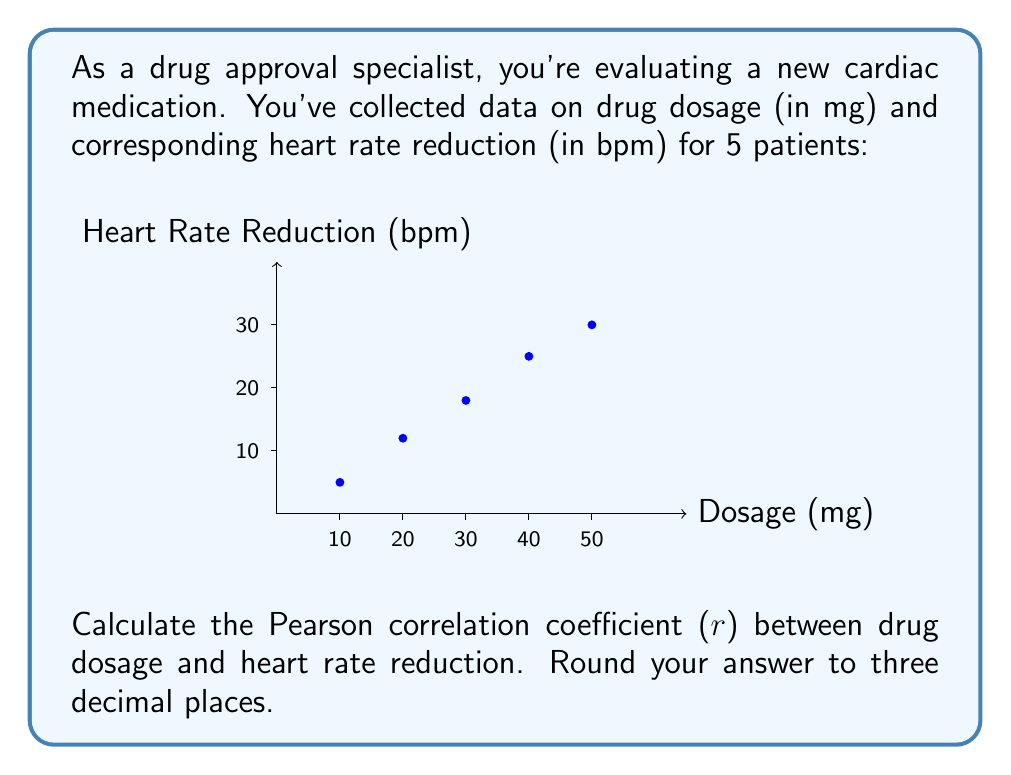Can you solve this math problem? To calculate the Pearson correlation coefficient, we'll use the formula:

$$ r = \frac{\sum_{i=1}^{n} (x_i - \bar{x})(y_i - \bar{y})}{\sqrt{\sum_{i=1}^{n} (x_i - \bar{x})^2} \sqrt{\sum_{i=1}^{n} (y_i - \bar{y})^2}} $$

Where:
$x_i$ = drug dosage
$y_i$ = heart rate reduction
$\bar{x}$ = mean drug dosage
$\bar{y}$ = mean heart rate reduction
$n$ = number of data points (5)

Step 1: Calculate means
$\bar{x} = \frac{10 + 20 + 30 + 40 + 50}{5} = 30$
$\bar{y} = \frac{5 + 12 + 18 + 25 + 30}{5} = 18$

Step 2: Calculate $(x_i - \bar{x})$, $(y_i - \bar{y})$, $(x_i - \bar{x})^2$, $(y_i - \bar{y})^2$, and $(x_i - \bar{x})(y_i - \bar{y})$

| $x_i$ | $y_i$ | $x_i - \bar{x}$ | $y_i - \bar{y}$ | $(x_i - \bar{x})^2$ | $(y_i - \bar{y})^2$ | $(x_i - \bar{x})(y_i - \bar{y})$ |
|-------|-------|-----------------|-----------------|---------------------|---------------------|----------------------------------|
| 10    | 5     | -20             | -13             | 400                 | 169                 | 260                              |
| 20    | 12    | -10             | -6              | 100                 | 36                  | 60                               |
| 30    | 18    | 0               | 0               | 0                   | 0                   | 0                                |
| 40    | 25    | 10              | 7               | 100                 | 49                  | 70                               |
| 50    | 30    | 20              | 12              | 400                 | 144                 | 240                              |

Step 3: Sum the columns
$\sum (x_i - \bar{x})^2 = 1000$
$\sum (y_i - \bar{y})^2 = 398$
$\sum (x_i - \bar{x})(y_i - \bar{y}) = 630$

Step 4: Apply the formula
$$ r = \frac{630}{\sqrt{1000} \sqrt{398}} = \frac{630}{\sqrt{398000}} = \frac{630}{630.872} \approx 0.998 $$
Answer: $0.998$ 